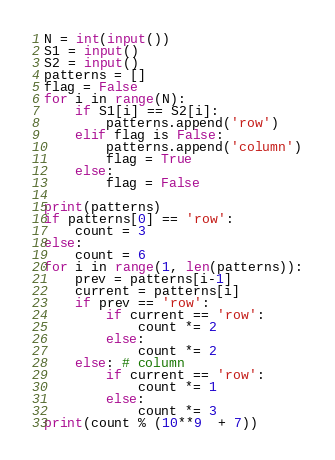Convert code to text. <code><loc_0><loc_0><loc_500><loc_500><_Python_>N = int(input())
S1 = input()
S2 = input()
patterns = []
flag = False
for i in range(N):
    if S1[i] == S2[i]:
        patterns.append('row')
    elif flag is False:
        patterns.append('column')
        flag = True
    else:
        flag = False

print(patterns)
if patterns[0] == 'row':
    count = 3
else:
    count = 6
for i in range(1, len(patterns)):
    prev = patterns[i-1]
    current = patterns[i]
    if prev == 'row':
        if current == 'row':
            count *= 2
        else:
            count *= 2
    else: # column
        if current == 'row':
            count *= 1
        else:
            count *= 3
print(count % (10**9  + 7))</code> 